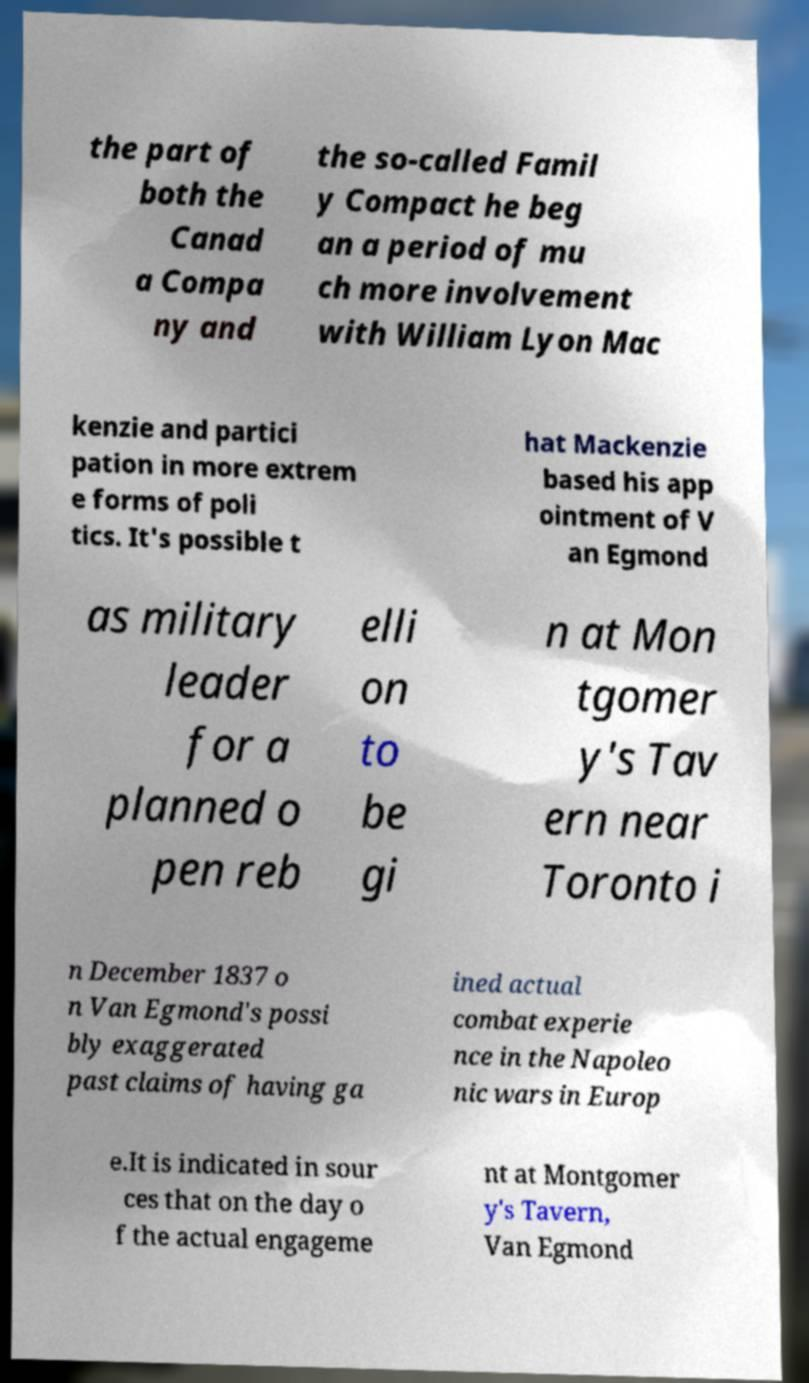Can you read and provide the text displayed in the image?This photo seems to have some interesting text. Can you extract and type it out for me? the part of both the Canad a Compa ny and the so-called Famil y Compact he beg an a period of mu ch more involvement with William Lyon Mac kenzie and partici pation in more extrem e forms of poli tics. It's possible t hat Mackenzie based his app ointment of V an Egmond as military leader for a planned o pen reb elli on to be gi n at Mon tgomer y's Tav ern near Toronto i n December 1837 o n Van Egmond's possi bly exaggerated past claims of having ga ined actual combat experie nce in the Napoleo nic wars in Europ e.It is indicated in sour ces that on the day o f the actual engageme nt at Montgomer y's Tavern, Van Egmond 